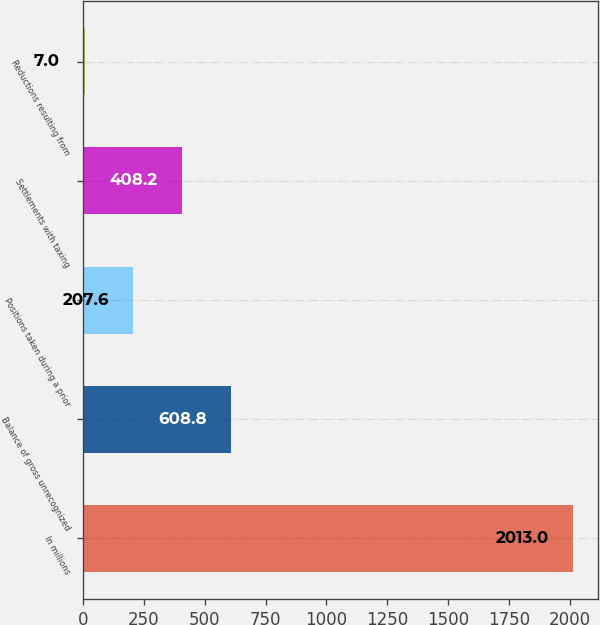<chart> <loc_0><loc_0><loc_500><loc_500><bar_chart><fcel>In millions<fcel>Balance of gross unrecognized<fcel>Positions taken during a prior<fcel>Settlements with taxing<fcel>Reductions resulting from<nl><fcel>2013<fcel>608.8<fcel>207.6<fcel>408.2<fcel>7<nl></chart> 